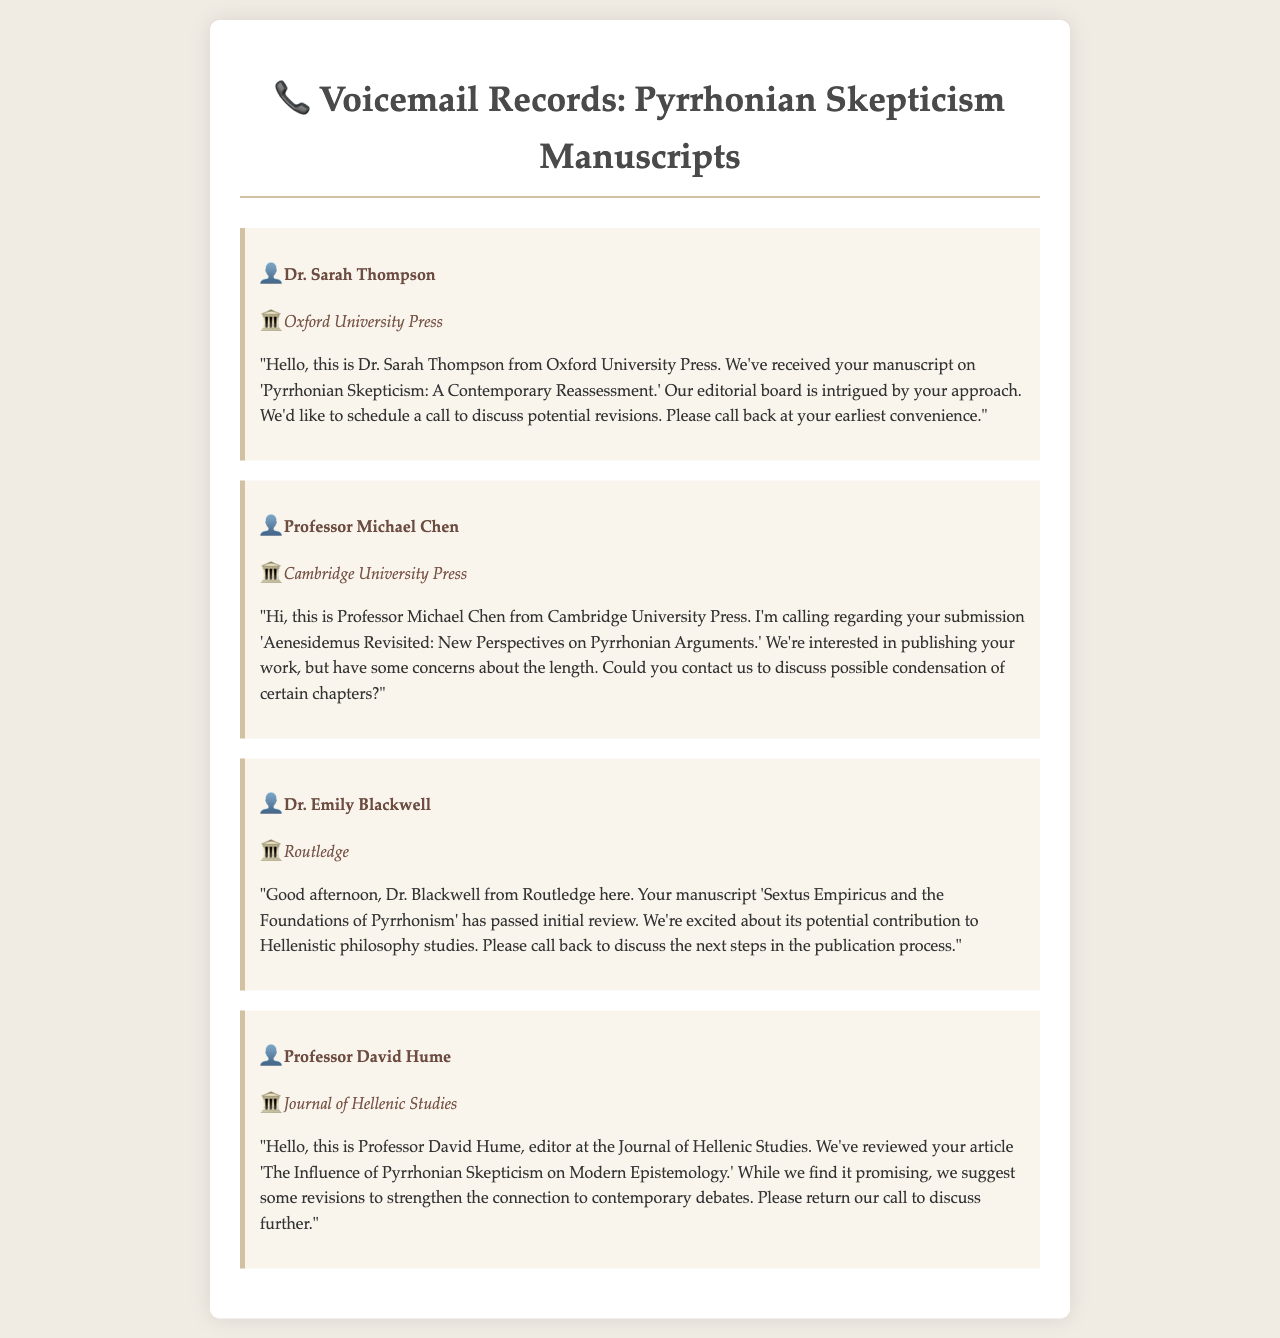What is the name of the first caller? The first caller is Dr. Sarah Thompson, as listed in the document.
Answer: Dr. Sarah Thompson Which publisher is associated with the manuscript about Aenesidemus? The publisher for the manuscript 'Aenesidemus Revisited: New Perspectives on Pyrrhonian Arguments' is Cambridge University Press.
Answer: Cambridge University Press What is the title of Dr. Blackwell's manuscript? Dr. Blackwell's manuscript is titled 'Sextus Empiricus and the Foundations of Pyrrhonism'.
Answer: Sextus Empiricus and the Foundations of Pyrrhonism How many voicemail messages are there in total? There are four voicemail messages presented in the document.
Answer: Four What specific concern does Professor Michael Chen mention? Professor Michael Chen expresses concern about the length of the manuscript.
Answer: Length What potential contribution is mentioned for Dr. Blackwell's manuscript? The document notes the potential contribution to Hellenistic philosophy studies.
Answer: Hellenistic philosophy studies What is the publication status of Dr. Blackwell's manuscript? Dr. Blackwell's manuscript has passed initial review.
Answer: Passed initial review Which article is under review by the Journal of Hellenic Studies? The article under review is titled 'The Influence of Pyrrhonian Skepticism on Modern Epistemology'.
Answer: The Influence of Pyrrhonian Skepticism on Modern Epistemology 